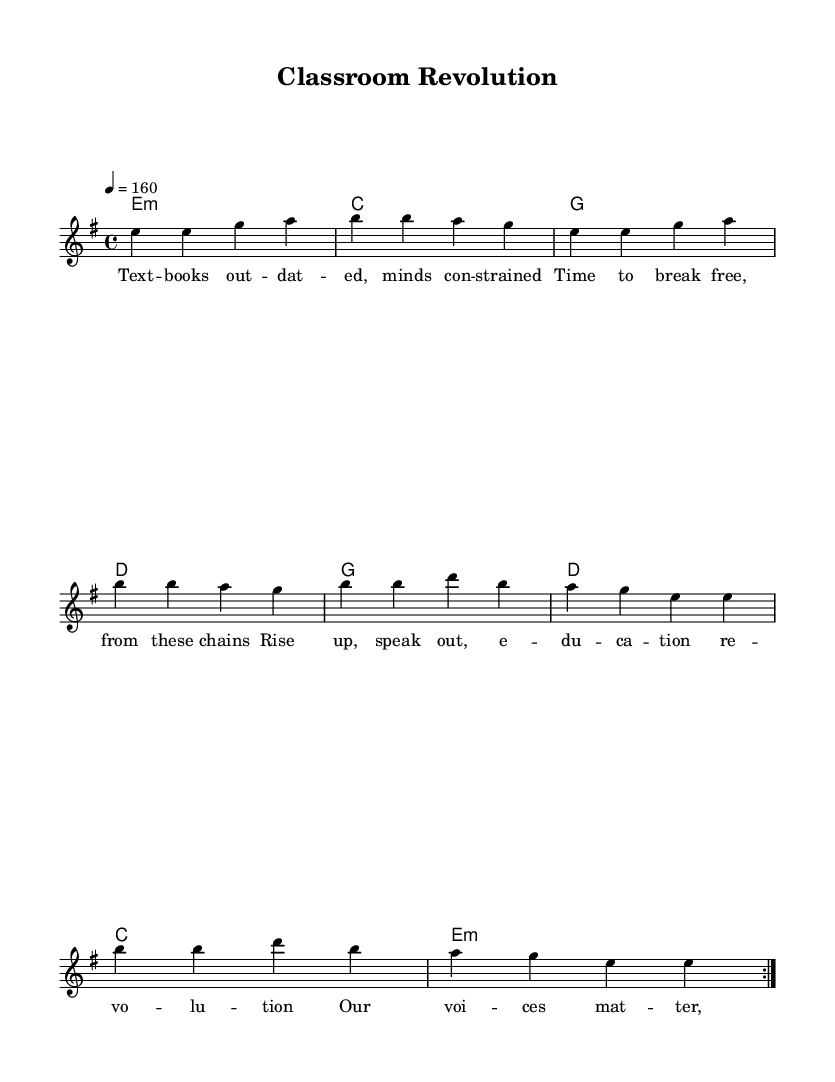What is the key signature of this music? The key signature indicated in the music is E minor, which has one sharp (F#). You can identify this by looking at the key signature notation at the beginning of the sheet music.
Answer: E minor What is the time signature of this music? The time signature is 4/4, which is indicated at the beginning of the piece. This means there are 4 beats in each measure, and each quarter note gets one beat.
Answer: 4/4 What is the tempo marking for this composition? The tempo marking is given as "4 = 160," which means the quarter note is to be played at a speed of 160 beats per minute. This is typically notated above the staff at the beginning of the piece.
Answer: 160 How many measures are there in the repeated section? The repeated section indicated by "volta 2" consists of a total of 8 measures before it repeats, as the repeat signs outline the portion that is played twice.
Answer: 8 What is the primary theme of the lyrics? The lyrics prominently address themes of educational reform and empowerment, evident from phrases like "education revolution" and "our voices matter." The context of these phrases points towards a protest or call to action regarding educational systems.
Answer: Educational reform Which chord appears most frequently in the harmony section? The most frequently occurring chord in the harmony section is E minor, as it is the last chord in each of the two repeats and appears prominently throughout the piece.
Answer: E minor What is the song style based on its structure and themes? The structure of the song, combined with its themes of rebellion and empowerment, indicates that it is a punk rock song. The characteristics typical to punk music—direct lyrics and strong choruses—are reflected in this piece.
Answer: Punk rock 